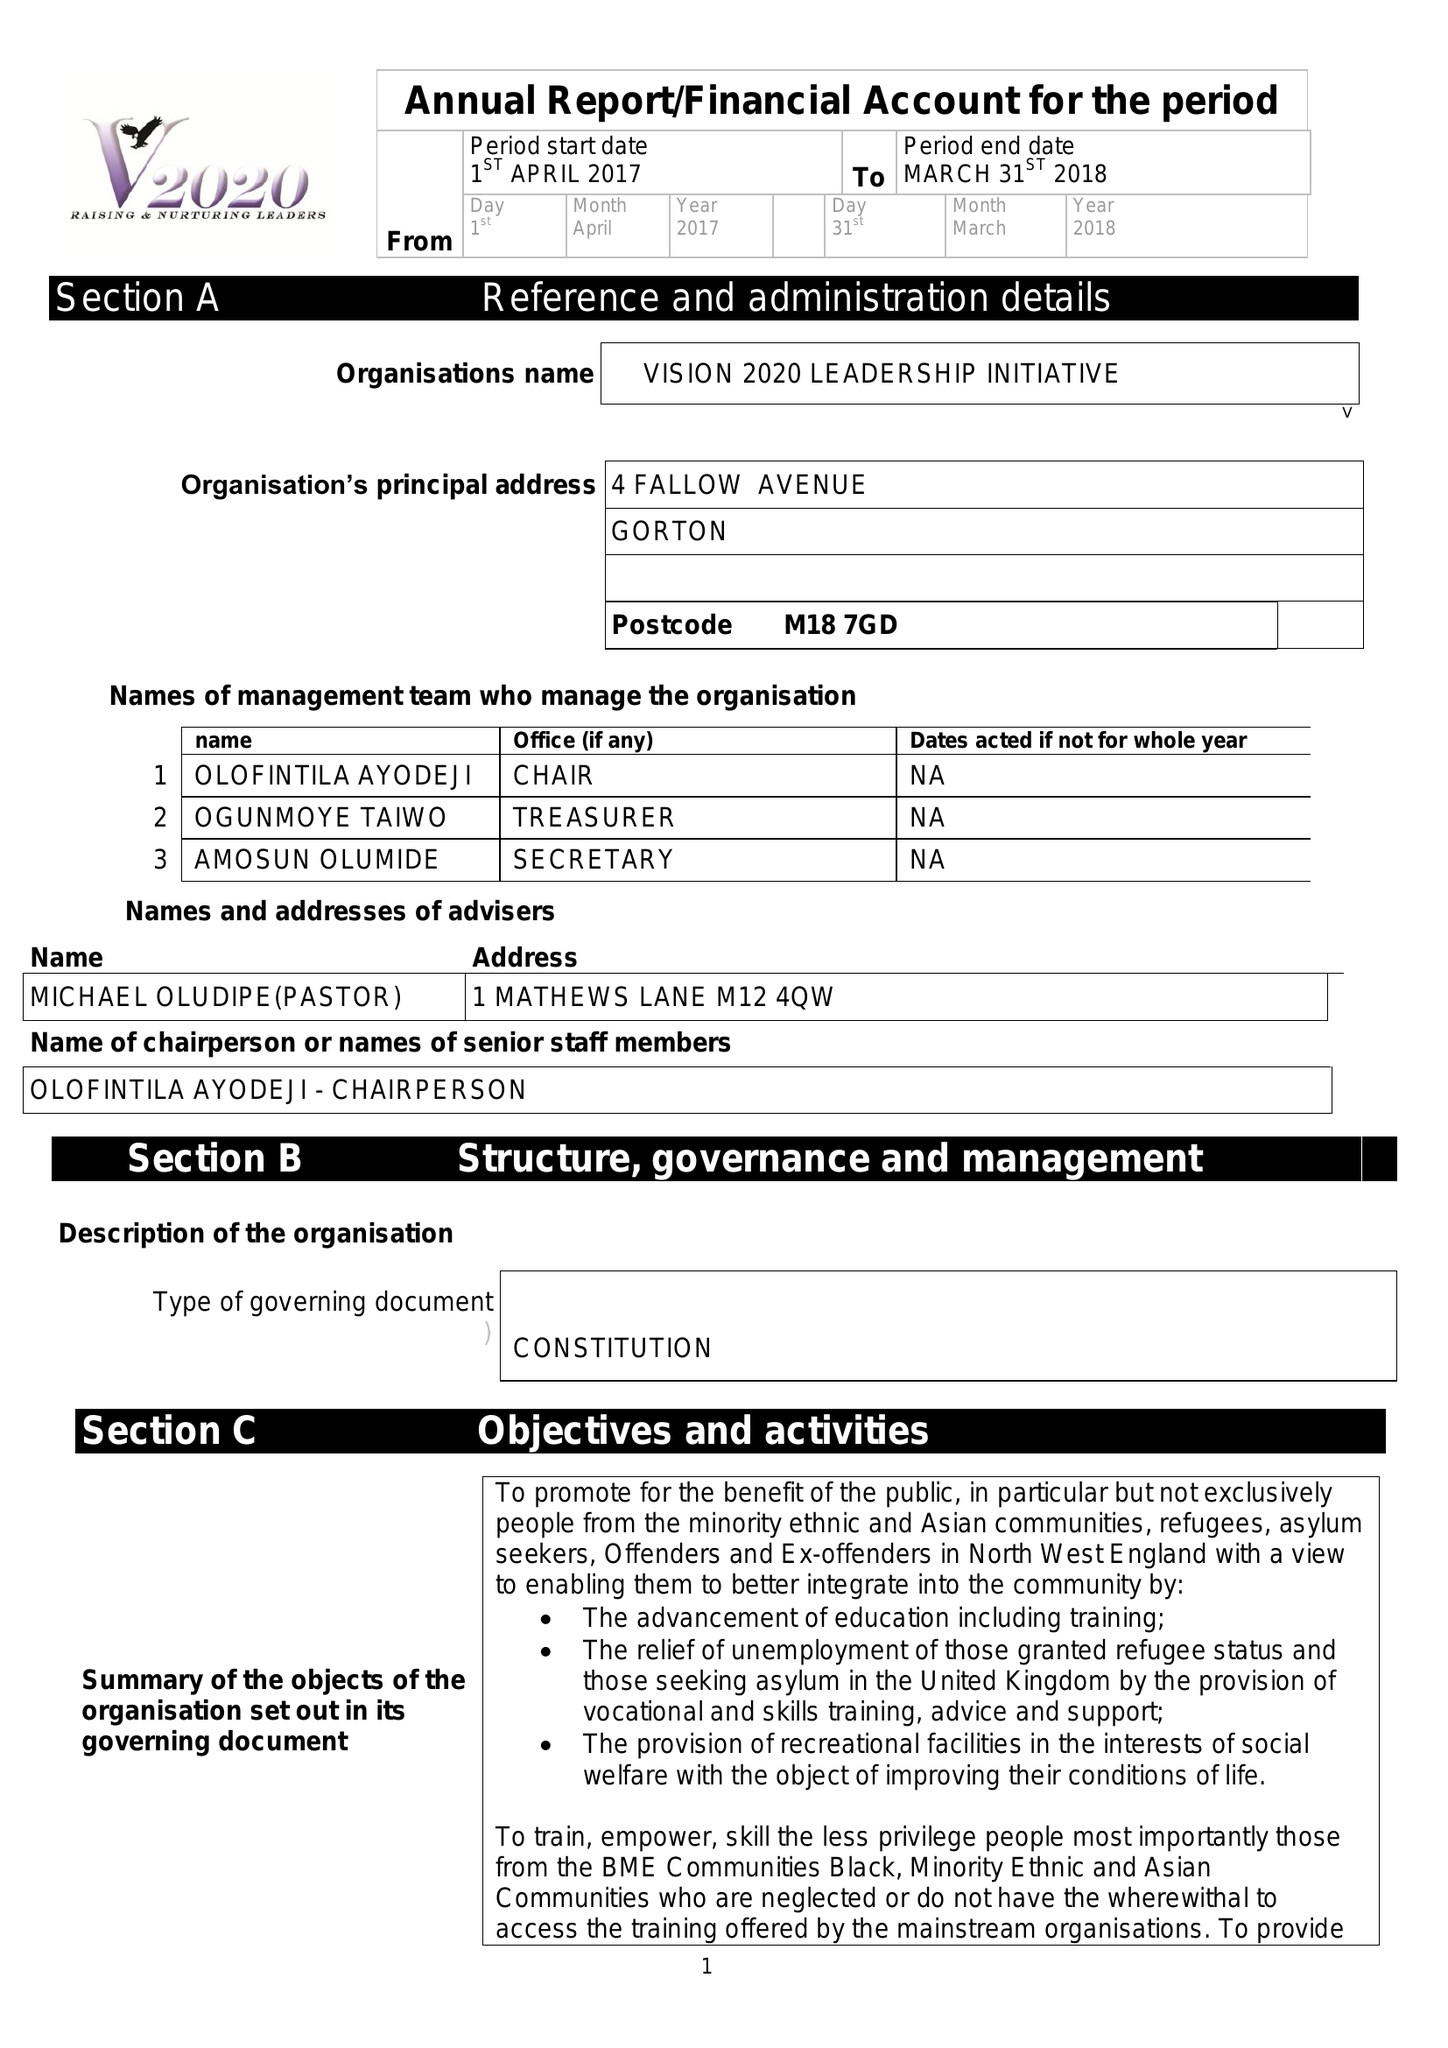What is the value for the income_annually_in_british_pounds?
Answer the question using a single word or phrase. 30197.00 